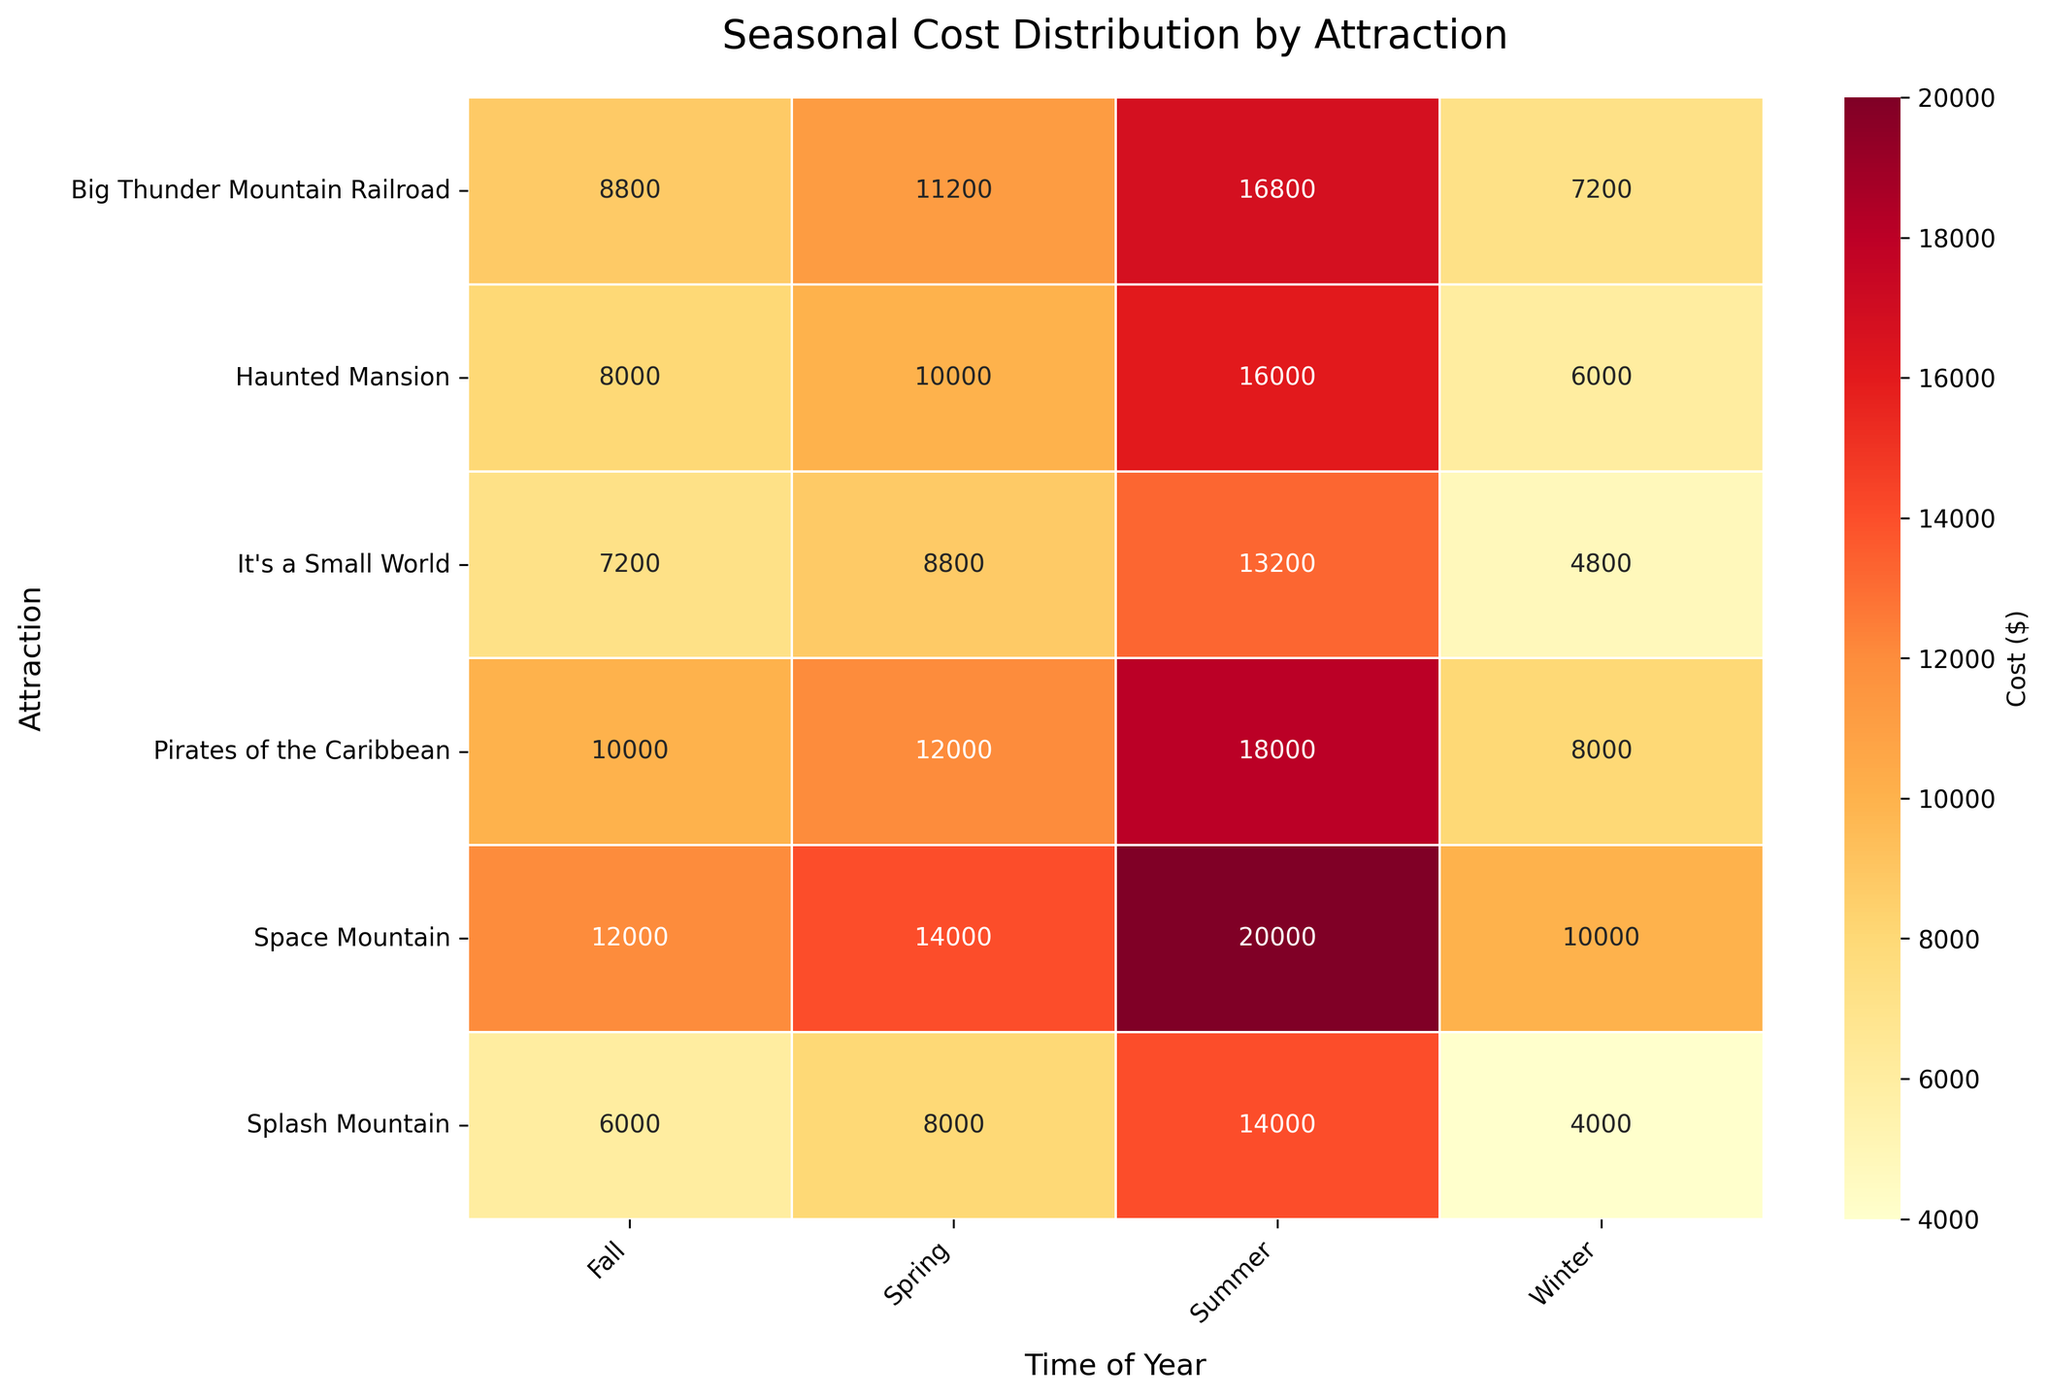What's the title of the heatmap? The title is typically located at the top of the figure. In this case, the title is "Seasonal Cost Distribution by Attraction."
Answer: Seasonal Cost Distribution by Attraction Which season has the highest cost for Splash Mountain? By looking at the row corresponding to Splash Mountain, the highest value among Winter, Spring, Summer, and Fall is in the Summer column with a value of $14,000.
Answer: Summer What is the total cost for all attractions in Winter? Add up the Winter costs for each attraction: 10,000 (Space Mountain) + 8,000 (Pirates of the Caribbean) + 6,000 (Haunted Mansion) + 4,000 (Splash Mountain) + 7,200 (Big Thunder Mountain Railroad) + 4,800 (It's a Small World) = 40,000.
Answer: 40,000 Which attraction has the lowest cost in Spring? By examining the Spring column, the lowest value is for Splash Mountain, which is $8,000.
Answer: Splash Mountain How does the cost of Space Mountain in Summer compare to its cost in Fall? According to the heatmap, Space Mountain's costs are $20,000 in Summer and $12,000 in Fall. So, Summer is $8,000 more expensive than Fall.
Answer: Summer is $8,000 more What is the average cost for Big Thunder Mountain Railroad across all seasons? Calculate the average by adding the costs across Winter, Spring, Summer, and Fall and dividing by 4: (7,200 + 11,200 + 16,800 + 8,800) / 4 = 11,500.
Answer: 11,500 Which season generally has the highest cost across all attractions? Summing the costs for all attractions in each season and comparing:
- Winter: 10,000 + 8,000 + 6,000 + 4,000 + 7,200 + 4,800 = 40,000
- Spring: 14,000 + 12,000 + 10,000 + 8,000 + 11,200 + 8,800 = 64,000
- Summer: 20,000 + 18,000 + 16,000 + 14,000 + 16,800 + 13,200 = 98,000
- Fall: 12,000 + 10,000 + 8,000 + 6,000 + 8,800 + 7,200 = 52,000
Summer has the highest total cost with 98,000.
Answer: Summer What is the difference in cost between the most expensive season and the least expensive season for Pirates of the Caribbean? The most expensive season for Pirates of the Caribbean is Summer ($18,000) and the least expensive is Winter ($8,000). The difference is 18,000 - 8,000 = 10,000.
Answer: 10,000 What is the median cost for all attractions in Fall? First, list the Fall costs in order: 6,000, 7,200, 8,000, 8,800, 10,000, 12,000. The median is the average of the two middle numbers: (8,800 + 8,000) / 2 = 8,400.
Answer: 8,400 